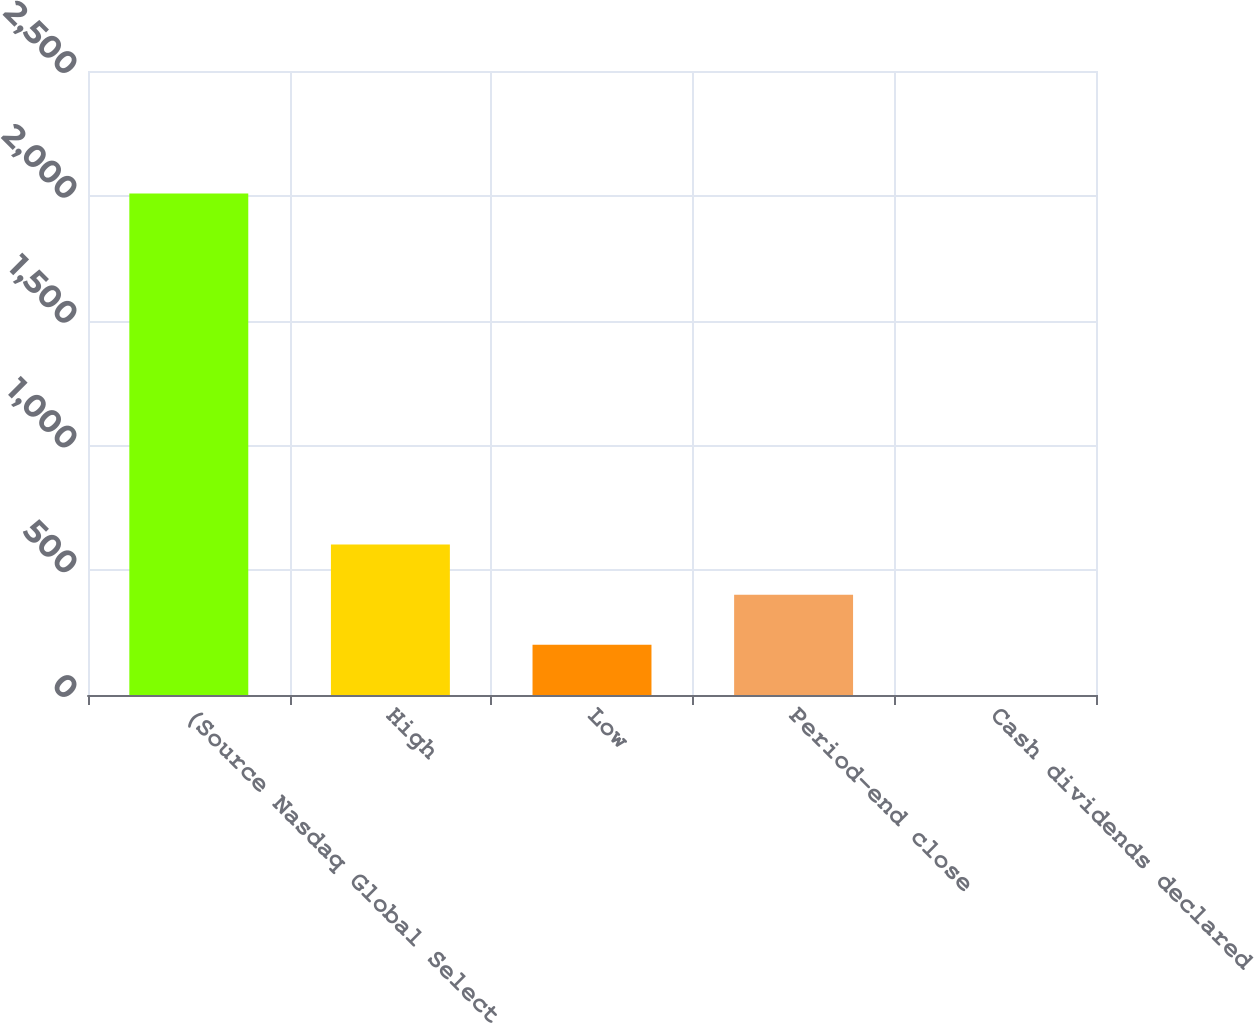<chart> <loc_0><loc_0><loc_500><loc_500><bar_chart><fcel>(Source Nasdaq Global Select<fcel>High<fcel>Low<fcel>Period-end close<fcel>Cash dividends declared<nl><fcel>2009<fcel>602.97<fcel>201.25<fcel>402.11<fcel>0.39<nl></chart> 